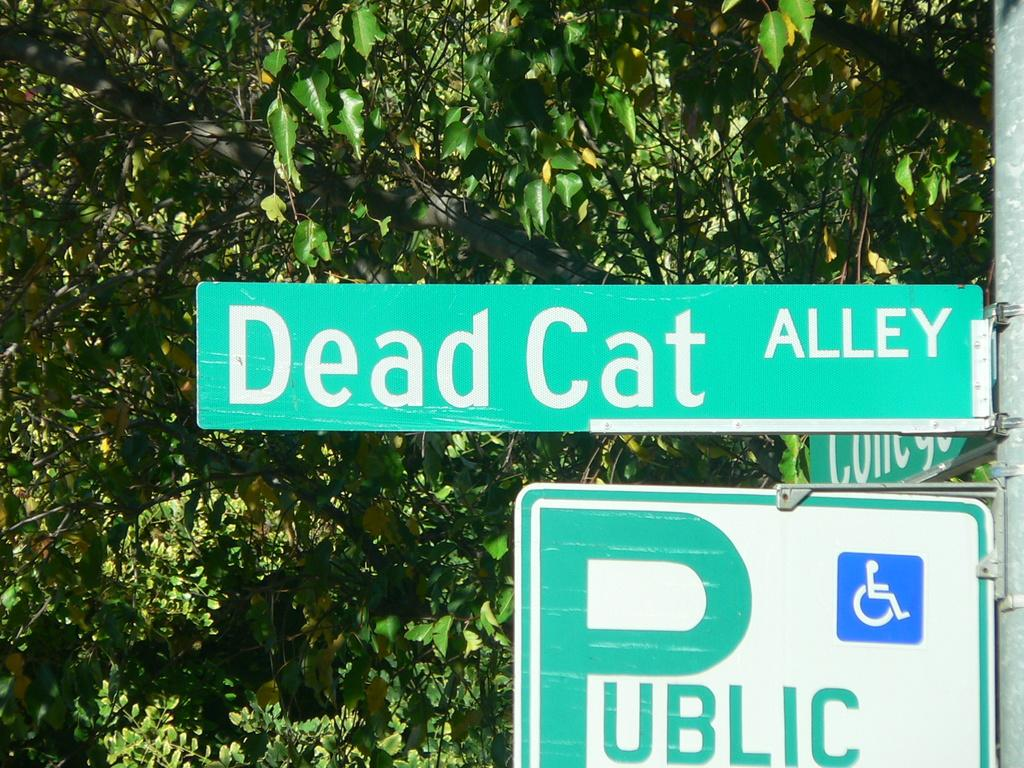<image>
Offer a succinct explanation of the picture presented. A public sign with a wheelchair symbol on the street Dead Cat Alley. 